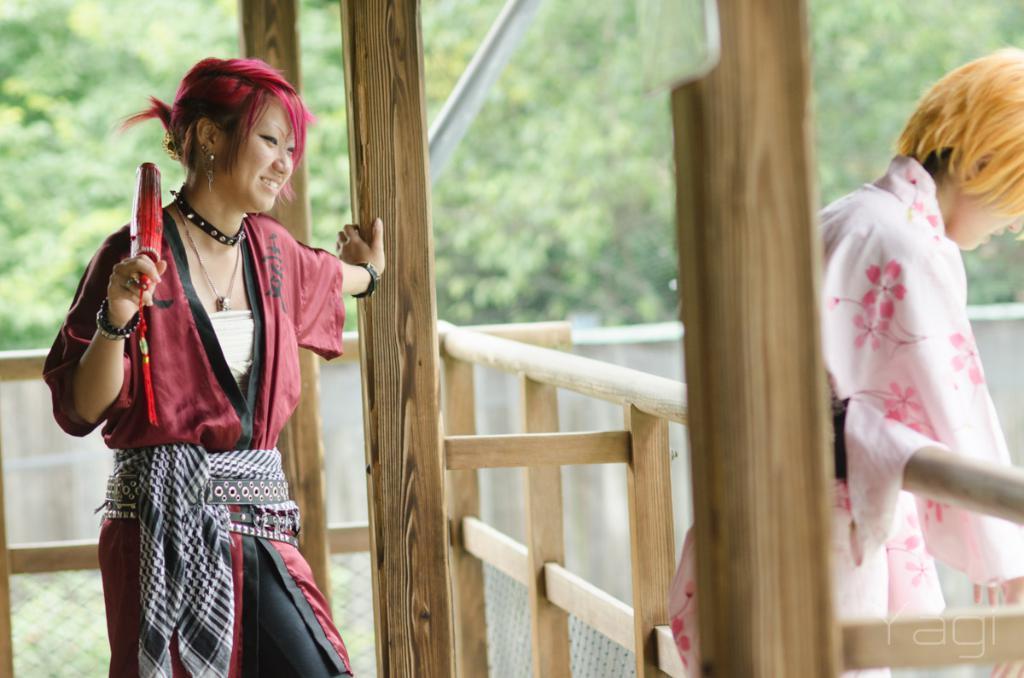Describe this image in one or two sentences. In this image I can see two people with different color dresses. In-between these people I can see the wooden fence and the poles. In the background I can see many trees. 